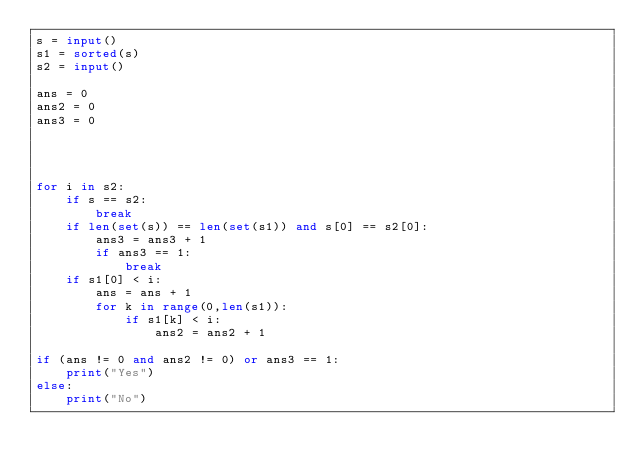Convert code to text. <code><loc_0><loc_0><loc_500><loc_500><_Python_>s = input()
s1 = sorted(s)
s2 = input()

ans = 0
ans2 = 0
ans3 = 0




for i in s2:
    if s == s2:
        break
    if len(set(s)) == len(set(s1)) and s[0] == s2[0]:
        ans3 = ans3 + 1
        if ans3 == 1:
            break
    if s1[0] < i:
        ans = ans + 1
        for k in range(0,len(s1)):
            if s1[k] < i:
                ans2 = ans2 + 1

if (ans != 0 and ans2 != 0) or ans3 == 1:
    print("Yes")
else:
    print("No")
</code> 